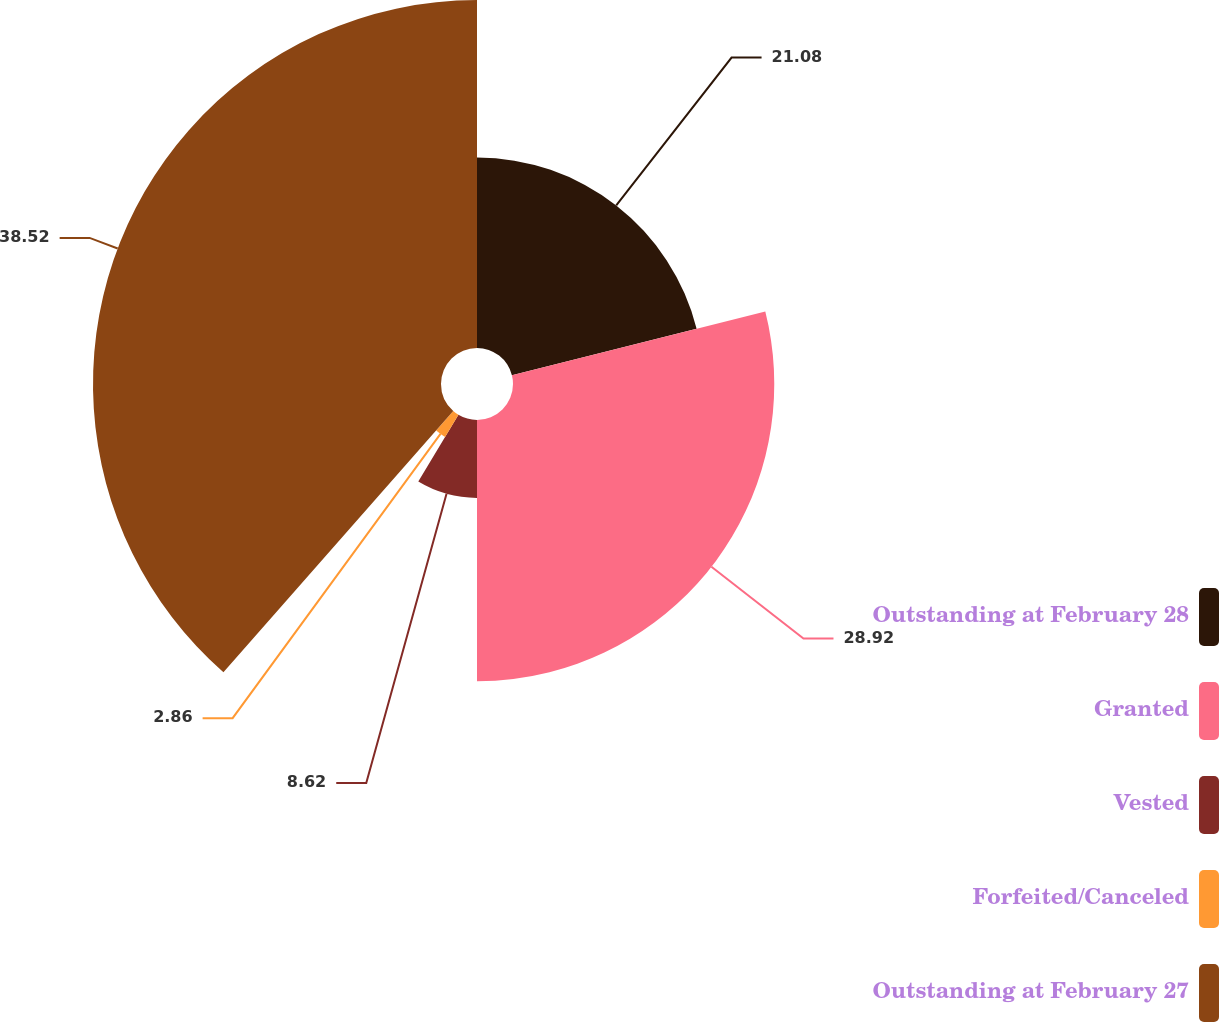<chart> <loc_0><loc_0><loc_500><loc_500><pie_chart><fcel>Outstanding at February 28<fcel>Granted<fcel>Vested<fcel>Forfeited/Canceled<fcel>Outstanding at February 27<nl><fcel>21.08%<fcel>28.92%<fcel>8.62%<fcel>2.86%<fcel>38.52%<nl></chart> 